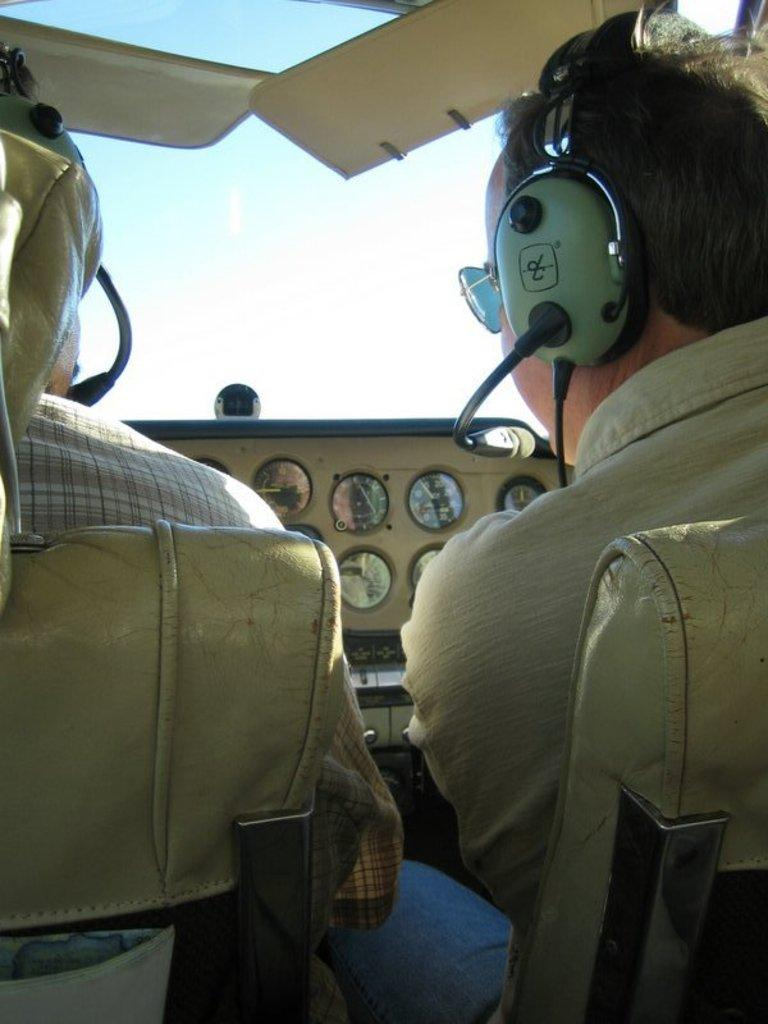How many people are in the image? There are two persons in the image. Where are the two persons located? The two persons are sitting in a cockpit. What type of chair is the police officer sitting on in the image? There is no police officer or chair present in the image. 